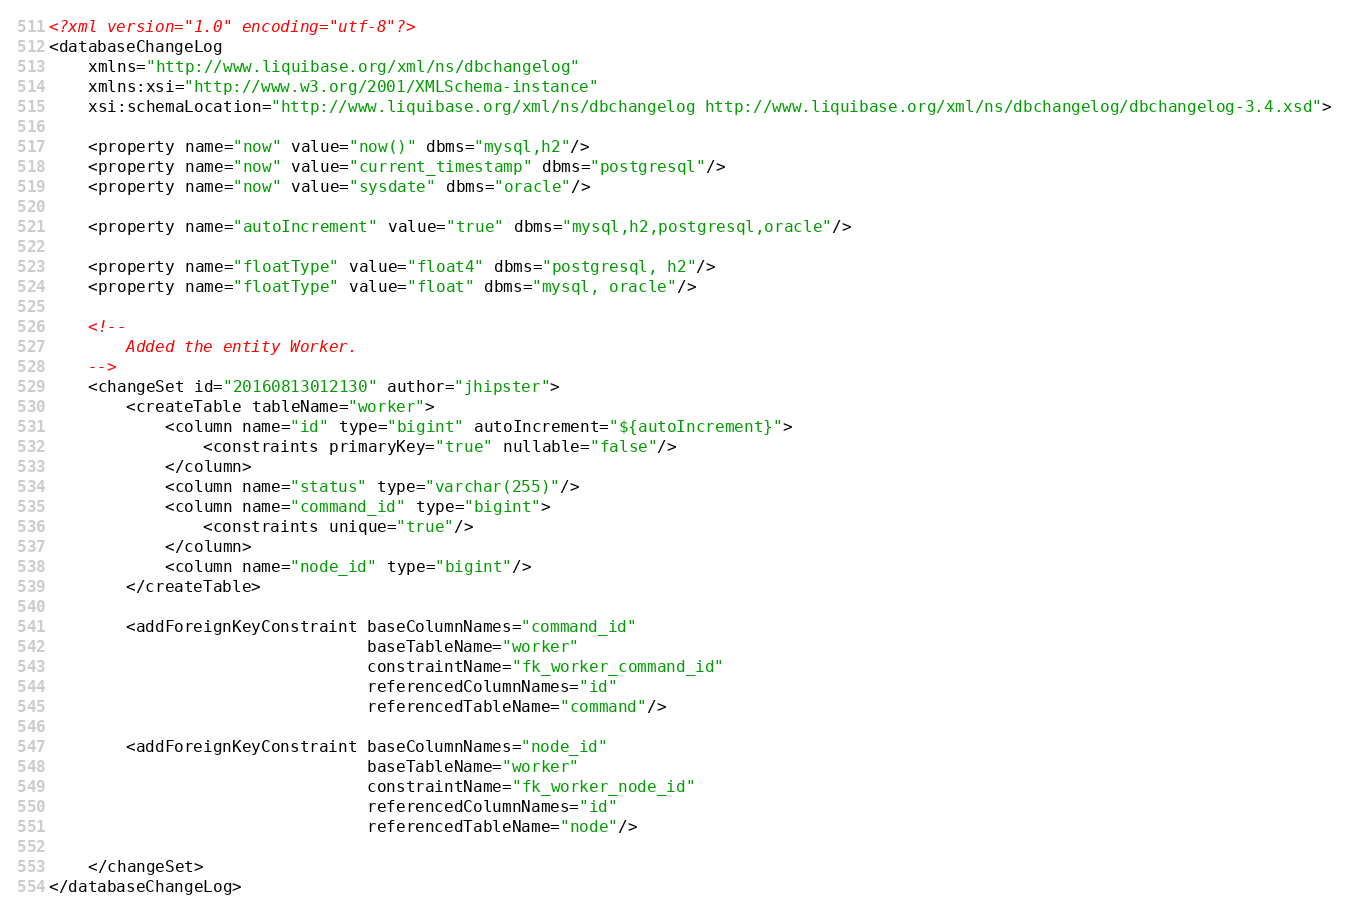<code> <loc_0><loc_0><loc_500><loc_500><_XML_><?xml version="1.0" encoding="utf-8"?>
<databaseChangeLog
    xmlns="http://www.liquibase.org/xml/ns/dbchangelog"
    xmlns:xsi="http://www.w3.org/2001/XMLSchema-instance"
    xsi:schemaLocation="http://www.liquibase.org/xml/ns/dbchangelog http://www.liquibase.org/xml/ns/dbchangelog/dbchangelog-3.4.xsd">

    <property name="now" value="now()" dbms="mysql,h2"/>
    <property name="now" value="current_timestamp" dbms="postgresql"/>
    <property name="now" value="sysdate" dbms="oracle"/>

    <property name="autoIncrement" value="true" dbms="mysql,h2,postgresql,oracle"/>

    <property name="floatType" value="float4" dbms="postgresql, h2"/>
    <property name="floatType" value="float" dbms="mysql, oracle"/>

    <!--
        Added the entity Worker.
    -->
    <changeSet id="20160813012130" author="jhipster">
        <createTable tableName="worker">
            <column name="id" type="bigint" autoIncrement="${autoIncrement}">
                <constraints primaryKey="true" nullable="false"/>
            </column>
            <column name="status" type="varchar(255)"/>
            <column name="command_id" type="bigint">
                <constraints unique="true"/>
            </column>
            <column name="node_id" type="bigint"/>
        </createTable>
        
        <addForeignKeyConstraint baseColumnNames="command_id"
                                 baseTableName="worker"
                                 constraintName="fk_worker_command_id"
                                 referencedColumnNames="id"
                                 referencedTableName="command"/>

        <addForeignKeyConstraint baseColumnNames="node_id"
                                 baseTableName="worker"
                                 constraintName="fk_worker_node_id"
                                 referencedColumnNames="id"
                                 referencedTableName="node"/>

    </changeSet>
</databaseChangeLog>
</code> 